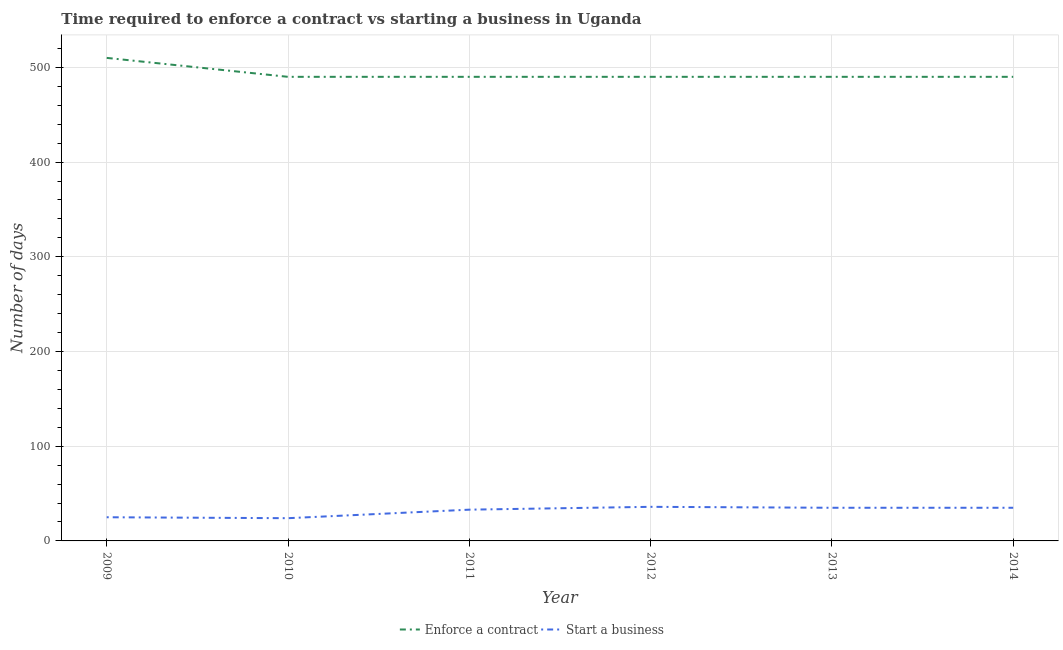Is the number of lines equal to the number of legend labels?
Provide a short and direct response. Yes. What is the number of days to start a business in 2011?
Your response must be concise. 33. Across all years, what is the maximum number of days to enforece a contract?
Ensure brevity in your answer.  510. Across all years, what is the minimum number of days to enforece a contract?
Offer a terse response. 490. In which year was the number of days to start a business maximum?
Offer a terse response. 2012. What is the total number of days to start a business in the graph?
Make the answer very short. 188. What is the difference between the number of days to start a business in 2011 and that in 2014?
Provide a short and direct response. -2. What is the difference between the number of days to start a business in 2014 and the number of days to enforece a contract in 2010?
Your answer should be compact. -455. What is the average number of days to enforece a contract per year?
Provide a short and direct response. 493.33. In the year 2014, what is the difference between the number of days to start a business and number of days to enforece a contract?
Give a very brief answer. -455. What is the ratio of the number of days to enforece a contract in 2009 to that in 2011?
Provide a succinct answer. 1.04. What is the difference between the highest and the lowest number of days to start a business?
Make the answer very short. 12. In how many years, is the number of days to start a business greater than the average number of days to start a business taken over all years?
Give a very brief answer. 4. Is the sum of the number of days to start a business in 2011 and 2012 greater than the maximum number of days to enforece a contract across all years?
Your response must be concise. No. Is the number of days to enforece a contract strictly greater than the number of days to start a business over the years?
Give a very brief answer. Yes. How many years are there in the graph?
Provide a short and direct response. 6. What is the difference between two consecutive major ticks on the Y-axis?
Keep it short and to the point. 100. Are the values on the major ticks of Y-axis written in scientific E-notation?
Your answer should be compact. No. Where does the legend appear in the graph?
Make the answer very short. Bottom center. How many legend labels are there?
Make the answer very short. 2. How are the legend labels stacked?
Your answer should be very brief. Horizontal. What is the title of the graph?
Offer a very short reply. Time required to enforce a contract vs starting a business in Uganda. What is the label or title of the X-axis?
Your answer should be very brief. Year. What is the label or title of the Y-axis?
Offer a very short reply. Number of days. What is the Number of days of Enforce a contract in 2009?
Offer a terse response. 510. What is the Number of days of Start a business in 2009?
Provide a succinct answer. 25. What is the Number of days of Enforce a contract in 2010?
Offer a terse response. 490. What is the Number of days of Start a business in 2010?
Your response must be concise. 24. What is the Number of days in Enforce a contract in 2011?
Provide a succinct answer. 490. What is the Number of days of Start a business in 2011?
Ensure brevity in your answer.  33. What is the Number of days of Enforce a contract in 2012?
Provide a succinct answer. 490. What is the Number of days of Start a business in 2012?
Provide a succinct answer. 36. What is the Number of days in Enforce a contract in 2013?
Ensure brevity in your answer.  490. What is the Number of days in Enforce a contract in 2014?
Offer a very short reply. 490. What is the Number of days of Start a business in 2014?
Offer a terse response. 35. Across all years, what is the maximum Number of days of Enforce a contract?
Provide a succinct answer. 510. Across all years, what is the maximum Number of days in Start a business?
Offer a terse response. 36. Across all years, what is the minimum Number of days of Enforce a contract?
Give a very brief answer. 490. What is the total Number of days in Enforce a contract in the graph?
Your response must be concise. 2960. What is the total Number of days in Start a business in the graph?
Make the answer very short. 188. What is the difference between the Number of days of Enforce a contract in 2009 and that in 2010?
Keep it short and to the point. 20. What is the difference between the Number of days in Start a business in 2009 and that in 2010?
Your response must be concise. 1. What is the difference between the Number of days in Enforce a contract in 2009 and that in 2013?
Provide a succinct answer. 20. What is the difference between the Number of days in Enforce a contract in 2009 and that in 2014?
Provide a succinct answer. 20. What is the difference between the Number of days of Enforce a contract in 2010 and that in 2013?
Offer a very short reply. 0. What is the difference between the Number of days of Enforce a contract in 2010 and that in 2014?
Give a very brief answer. 0. What is the difference between the Number of days in Start a business in 2010 and that in 2014?
Offer a terse response. -11. What is the difference between the Number of days of Start a business in 2011 and that in 2014?
Give a very brief answer. -2. What is the difference between the Number of days of Enforce a contract in 2012 and that in 2013?
Ensure brevity in your answer.  0. What is the difference between the Number of days of Start a business in 2012 and that in 2013?
Offer a terse response. 1. What is the difference between the Number of days in Start a business in 2012 and that in 2014?
Keep it short and to the point. 1. What is the difference between the Number of days in Enforce a contract in 2013 and that in 2014?
Make the answer very short. 0. What is the difference between the Number of days of Start a business in 2013 and that in 2014?
Provide a short and direct response. 0. What is the difference between the Number of days in Enforce a contract in 2009 and the Number of days in Start a business in 2010?
Offer a terse response. 486. What is the difference between the Number of days of Enforce a contract in 2009 and the Number of days of Start a business in 2011?
Offer a very short reply. 477. What is the difference between the Number of days in Enforce a contract in 2009 and the Number of days in Start a business in 2012?
Make the answer very short. 474. What is the difference between the Number of days of Enforce a contract in 2009 and the Number of days of Start a business in 2013?
Provide a short and direct response. 475. What is the difference between the Number of days of Enforce a contract in 2009 and the Number of days of Start a business in 2014?
Your response must be concise. 475. What is the difference between the Number of days in Enforce a contract in 2010 and the Number of days in Start a business in 2011?
Ensure brevity in your answer.  457. What is the difference between the Number of days in Enforce a contract in 2010 and the Number of days in Start a business in 2012?
Provide a short and direct response. 454. What is the difference between the Number of days in Enforce a contract in 2010 and the Number of days in Start a business in 2013?
Provide a succinct answer. 455. What is the difference between the Number of days in Enforce a contract in 2010 and the Number of days in Start a business in 2014?
Make the answer very short. 455. What is the difference between the Number of days of Enforce a contract in 2011 and the Number of days of Start a business in 2012?
Your answer should be very brief. 454. What is the difference between the Number of days of Enforce a contract in 2011 and the Number of days of Start a business in 2013?
Offer a very short reply. 455. What is the difference between the Number of days of Enforce a contract in 2011 and the Number of days of Start a business in 2014?
Make the answer very short. 455. What is the difference between the Number of days of Enforce a contract in 2012 and the Number of days of Start a business in 2013?
Provide a succinct answer. 455. What is the difference between the Number of days of Enforce a contract in 2012 and the Number of days of Start a business in 2014?
Make the answer very short. 455. What is the difference between the Number of days in Enforce a contract in 2013 and the Number of days in Start a business in 2014?
Keep it short and to the point. 455. What is the average Number of days of Enforce a contract per year?
Make the answer very short. 493.33. What is the average Number of days in Start a business per year?
Keep it short and to the point. 31.33. In the year 2009, what is the difference between the Number of days in Enforce a contract and Number of days in Start a business?
Your answer should be very brief. 485. In the year 2010, what is the difference between the Number of days in Enforce a contract and Number of days in Start a business?
Ensure brevity in your answer.  466. In the year 2011, what is the difference between the Number of days of Enforce a contract and Number of days of Start a business?
Ensure brevity in your answer.  457. In the year 2012, what is the difference between the Number of days in Enforce a contract and Number of days in Start a business?
Offer a very short reply. 454. In the year 2013, what is the difference between the Number of days of Enforce a contract and Number of days of Start a business?
Give a very brief answer. 455. In the year 2014, what is the difference between the Number of days in Enforce a contract and Number of days in Start a business?
Make the answer very short. 455. What is the ratio of the Number of days of Enforce a contract in 2009 to that in 2010?
Make the answer very short. 1.04. What is the ratio of the Number of days of Start a business in 2009 to that in 2010?
Ensure brevity in your answer.  1.04. What is the ratio of the Number of days of Enforce a contract in 2009 to that in 2011?
Your answer should be very brief. 1.04. What is the ratio of the Number of days in Start a business in 2009 to that in 2011?
Give a very brief answer. 0.76. What is the ratio of the Number of days in Enforce a contract in 2009 to that in 2012?
Offer a very short reply. 1.04. What is the ratio of the Number of days of Start a business in 2009 to that in 2012?
Provide a short and direct response. 0.69. What is the ratio of the Number of days in Enforce a contract in 2009 to that in 2013?
Provide a short and direct response. 1.04. What is the ratio of the Number of days in Start a business in 2009 to that in 2013?
Offer a terse response. 0.71. What is the ratio of the Number of days in Enforce a contract in 2009 to that in 2014?
Your answer should be compact. 1.04. What is the ratio of the Number of days of Start a business in 2009 to that in 2014?
Ensure brevity in your answer.  0.71. What is the ratio of the Number of days in Start a business in 2010 to that in 2011?
Provide a short and direct response. 0.73. What is the ratio of the Number of days in Start a business in 2010 to that in 2012?
Your answer should be compact. 0.67. What is the ratio of the Number of days in Start a business in 2010 to that in 2013?
Provide a succinct answer. 0.69. What is the ratio of the Number of days in Enforce a contract in 2010 to that in 2014?
Offer a terse response. 1. What is the ratio of the Number of days in Start a business in 2010 to that in 2014?
Provide a short and direct response. 0.69. What is the ratio of the Number of days in Start a business in 2011 to that in 2012?
Your answer should be compact. 0.92. What is the ratio of the Number of days in Start a business in 2011 to that in 2013?
Your answer should be compact. 0.94. What is the ratio of the Number of days of Enforce a contract in 2011 to that in 2014?
Your answer should be compact. 1. What is the ratio of the Number of days in Start a business in 2011 to that in 2014?
Your answer should be compact. 0.94. What is the ratio of the Number of days in Enforce a contract in 2012 to that in 2013?
Make the answer very short. 1. What is the ratio of the Number of days in Start a business in 2012 to that in 2013?
Keep it short and to the point. 1.03. What is the ratio of the Number of days in Enforce a contract in 2012 to that in 2014?
Provide a succinct answer. 1. What is the ratio of the Number of days in Start a business in 2012 to that in 2014?
Provide a succinct answer. 1.03. What is the ratio of the Number of days of Start a business in 2013 to that in 2014?
Provide a succinct answer. 1. What is the difference between the highest and the second highest Number of days of Start a business?
Your response must be concise. 1. What is the difference between the highest and the lowest Number of days in Start a business?
Your answer should be very brief. 12. 